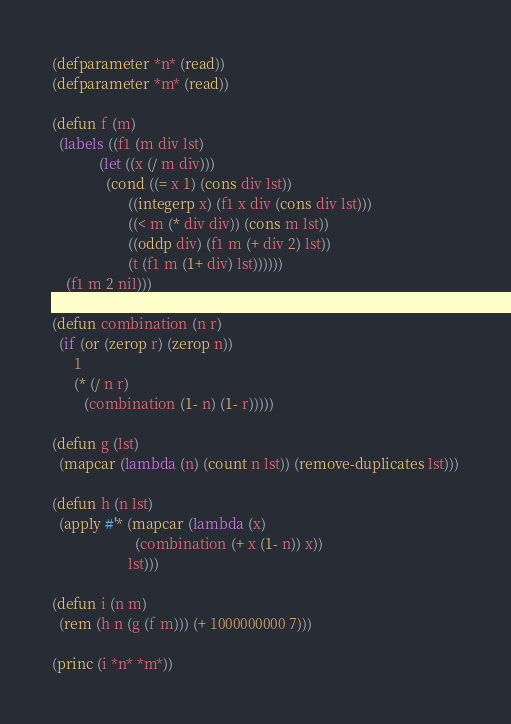<code> <loc_0><loc_0><loc_500><loc_500><_Lisp_>(defparameter *n* (read))
(defparameter *m* (read))

(defun f (m)
  (labels ((f1 (m div lst)
             (let ((x (/ m div)))
               (cond ((= x 1) (cons div lst))
                     ((integerp x) (f1 x div (cons div lst)))
                     ((< m (* div div)) (cons m lst))
                     ((oddp div) (f1 m (+ div 2) lst))
                     (t (f1 m (1+ div) lst))))))
    (f1 m 2 nil)))

(defun combination (n r)
  (if (or (zerop r) (zerop n))
      1
      (* (/ n r)
         (combination (1- n) (1- r)))))

(defun g (lst)
  (mapcar (lambda (n) (count n lst)) (remove-duplicates lst)))

(defun h (n lst)
  (apply #'* (mapcar (lambda (x)
                       (combination (+ x (1- n)) x))
                     lst)))

(defun i (n m)
  (rem (h n (g (f m))) (+ 1000000000 7)))

(princ (i *n* *m*))</code> 